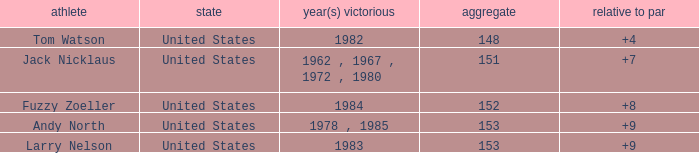What is the To par of the Player wtih Year(s) won of 1983? 9.0. 